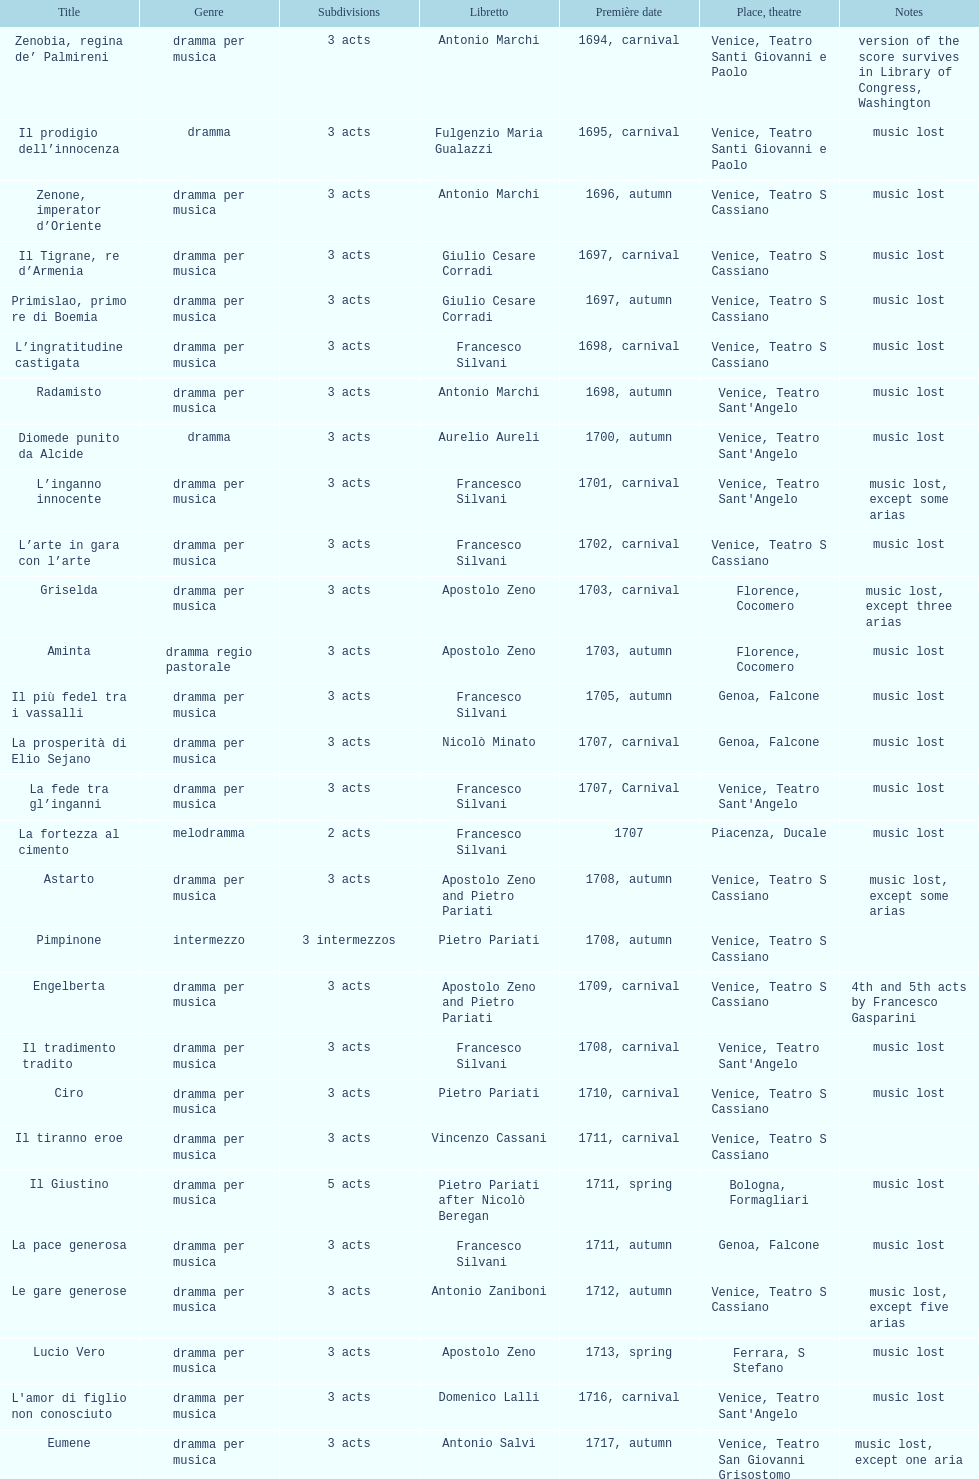Which was released earlier, artamene or merope? Merope. 